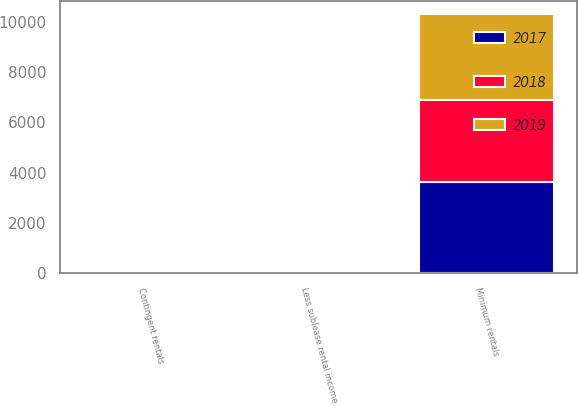<chart> <loc_0><loc_0><loc_500><loc_500><stacked_bar_chart><ecel><fcel>Minimum rentals<fcel>Contingent rentals<fcel>Less sublease rental income<nl><fcel>2017<fcel>3622<fcel>74<fcel>66<nl><fcel>2019<fcel>3447<fcel>68<fcel>67<nl><fcel>2018<fcel>3259<fcel>59<fcel>55<nl></chart> 